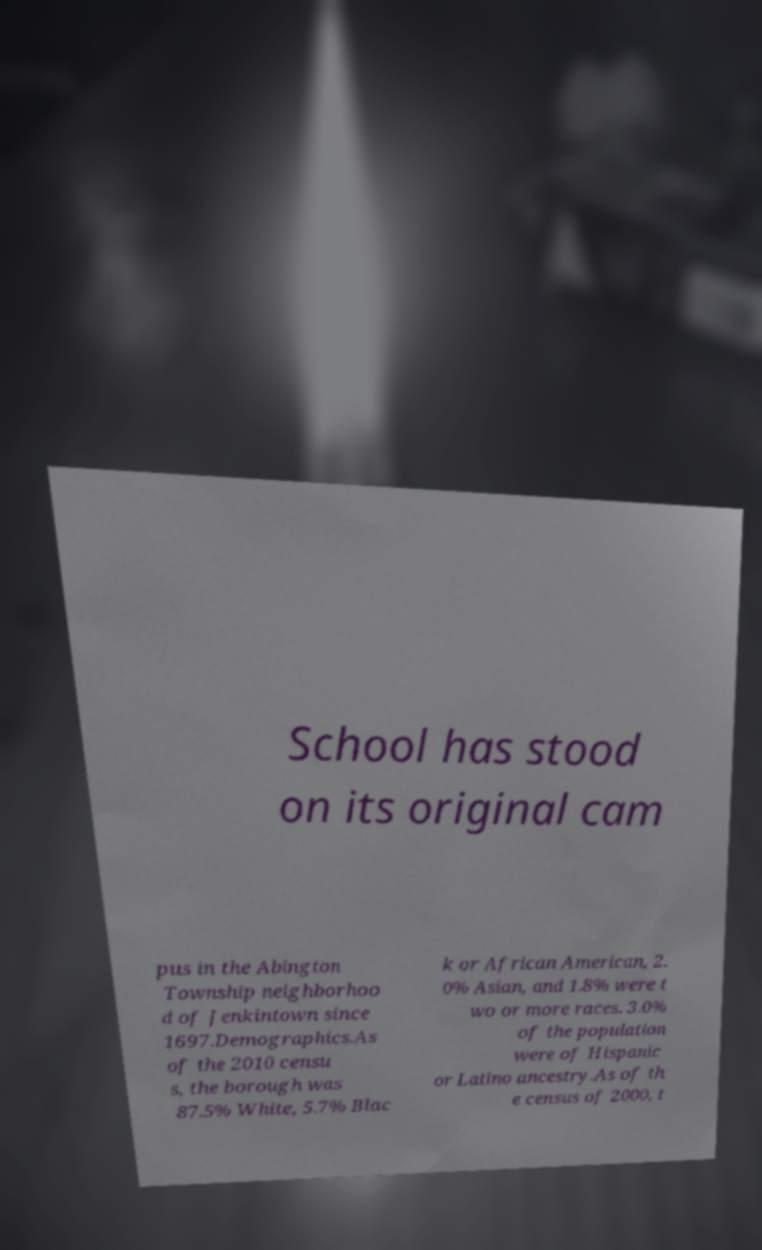Could you assist in decoding the text presented in this image and type it out clearly? School has stood on its original cam pus in the Abington Township neighborhoo d of Jenkintown since 1697.Demographics.As of the 2010 censu s, the borough was 87.5% White, 5.7% Blac k or African American, 2. 0% Asian, and 1.8% were t wo or more races. 3.0% of the population were of Hispanic or Latino ancestry.As of th e census of 2000, t 